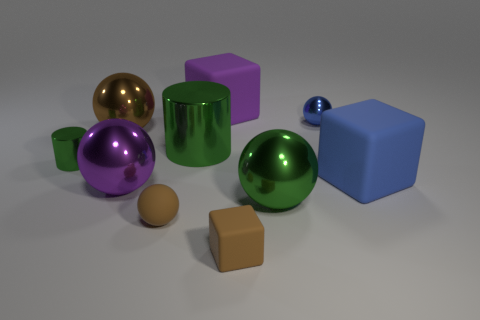Subtract all large blue rubber blocks. How many blocks are left? 2 Subtract all cylinders. How many objects are left? 8 Subtract 1 balls. How many balls are left? 4 Subtract all green balls. How many balls are left? 4 Add 7 large purple things. How many large purple things are left? 9 Add 1 small cyan metallic blocks. How many small cyan metallic blocks exist? 1 Subtract 0 cyan balls. How many objects are left? 10 Subtract all green spheres. Subtract all brown blocks. How many spheres are left? 4 Subtract all yellow blocks. How many brown balls are left? 2 Subtract all brown things. Subtract all big spheres. How many objects are left? 4 